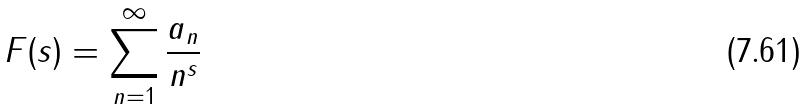Convert formula to latex. <formula><loc_0><loc_0><loc_500><loc_500>F ( s ) = \sum _ { n = 1 } ^ { \infty } \frac { a _ { n } } { n ^ { s } }</formula> 